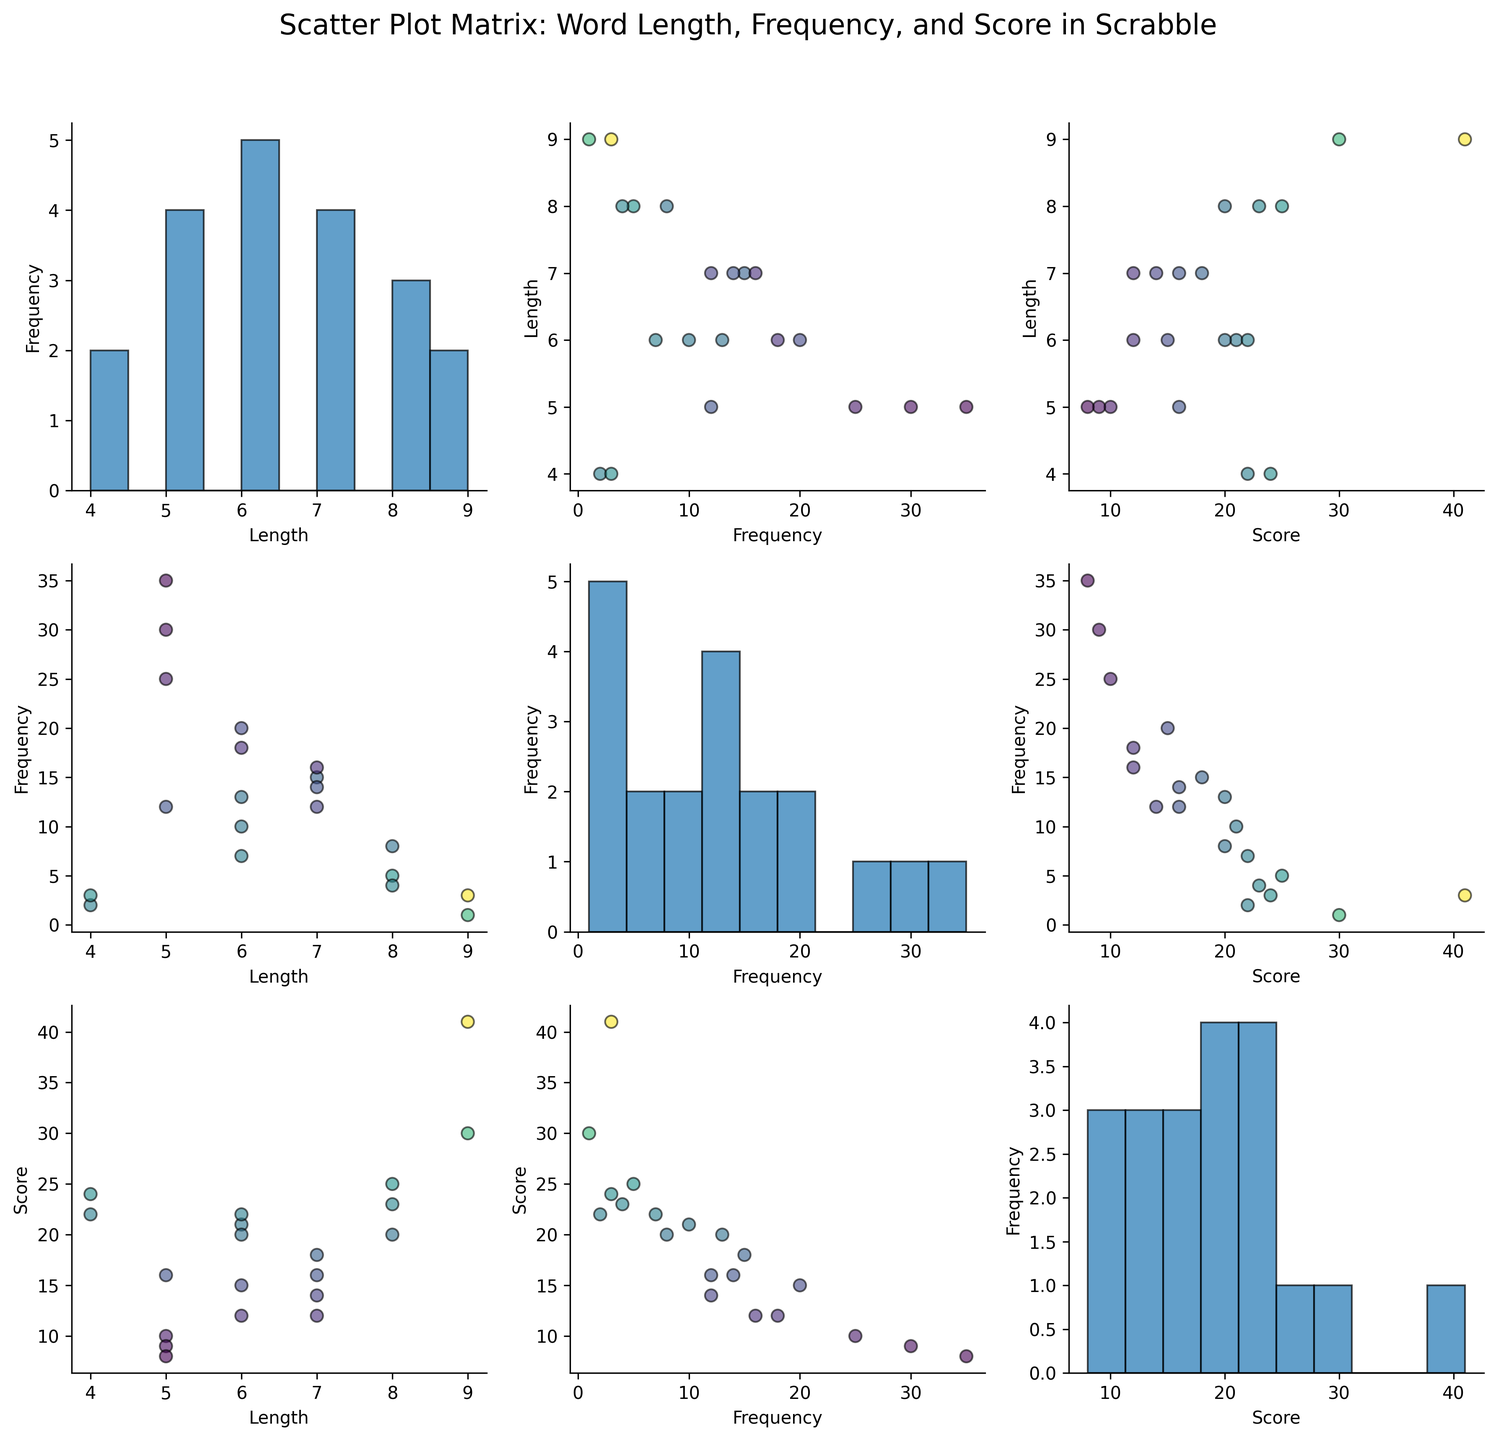what are the variables on the scatter plot matrix? The scatter plot matrix visualizes three variables: 'length' (the length of the word), 'frequency' (how often the word is used), and 'score' (the point value of the word in Scrabble). These variables are displayed along the axes in every combination.
Answer: length, frequency, score How is the relationship between frequency and score represented in the plot matrix? The relationship between frequency and score is represented by a scatter plot with frequency on the x-axis and score on the y-axis in the SPLOM. Each point represents a word, colored by its score, and the spread indicates how these two variables correlate.
Answer: scatter plot Which word length appears most frequently? To determine the most frequent word length, we look at the histogram along the diagonal where the variable "length" is plotted. We count the number of occurrences of each bar and compare their heights. The tallest bar represents the most frequent word length. The word length "5" appears most frequently.
Answer: 5 Is there a visible correlation between word length and score? Looking at the scatter plot of length vs. score, we see that data points do not form a clear linear pattern, indicating that there is no strong visible correlation between word length and score. The data points are rather dispersed with various lengths having a range of scores.
Answer: No strong correlation What is the correlation between word frequency and length? In the SPLOM, the scatter plot of frequency vs. length shows how frequency changes concerning word length. From a visual inspection, the spread of the points does not form a clear pattern, indicating no strong correlation between these variables.
Answer: No strong correlation How does word score typically change with increasing frequency? To examine this, we look at the scatter plot with frequency on the x-axis and score on the y-axis. There appears to be an inverse trend, where higher frequencies are often associated with lower scores, as the higher scores are mostly found with lower frequencies.
Answer: typically decreases Are any words both commonly used and high-scoring? In the frequency vs. score scatter plot, words that are both common and high-scoring would be in the upper-right region. However, it appears that higher scores are not associated with high frequencies, suggesting there are no words that meet both criteria.
Answer: No Which pair of variables shows the most scatter? By comparing all scatter plots in the matrix, the plot of length vs. score shows significant scatter with no clear trend, indicating a lot of variability in how these variables correlate.
Answer: length vs. score What is the distribution of Scrabble scores in the dataset? The distribution of Scrabble scores can be observed in the histogram on the diagonal corresponding to the score variable. This histogram reveals how often different scores occur. Scores appear to be widely distributed.
Answer: Wide distribution What does the color represent in this scatter plot matrix? The colors represent the score of the words, with each point shaded accordingly in the scatter plots. A color gradient helps visualize the different score values, using a colormap where variations in color indicate different score magnitudes.
Answer: score 